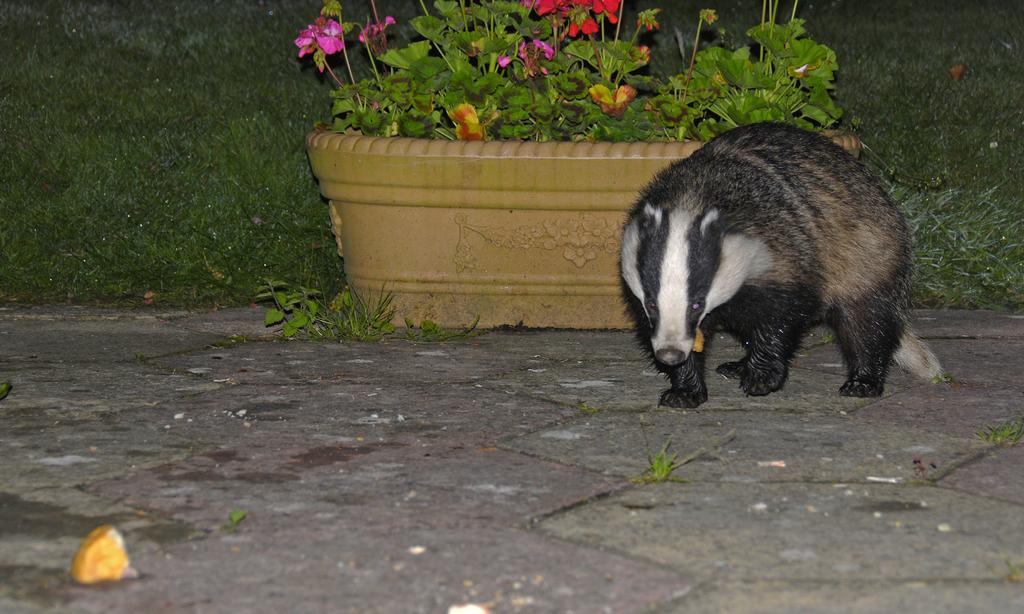How would you summarize this image in a sentence or two? In this picture we can see an animal standing on the ground behind which we have a big flower pot and grass. 